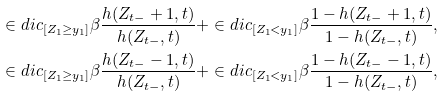<formula> <loc_0><loc_0><loc_500><loc_500>& \in d i c _ { [ { Z } _ { 1 } \geq y _ { 1 } ] } \beta \frac { h ( { Z } _ { t - } + 1 , t ) } { h ( { Z } _ { t - } , t ) } + \in d i c _ { [ { Z } _ { 1 } < y _ { 1 } ] } \beta \frac { 1 - h ( { Z } _ { t - } + 1 , t ) } { 1 - h ( { Z } _ { t - } , t ) } , \\ & \in d i c _ { [ { Z } _ { 1 } \geq y _ { 1 } ] } \beta \frac { h ( { Z } _ { t - } - 1 , t ) } { h ( { Z } _ { t - } , t ) } + \in d i c _ { [ { Z } _ { 1 } < y _ { 1 } ] } \beta \frac { 1 - h ( { Z } _ { t - } - 1 , t ) } { 1 - h ( { Z } _ { t - } , t ) } ,</formula> 